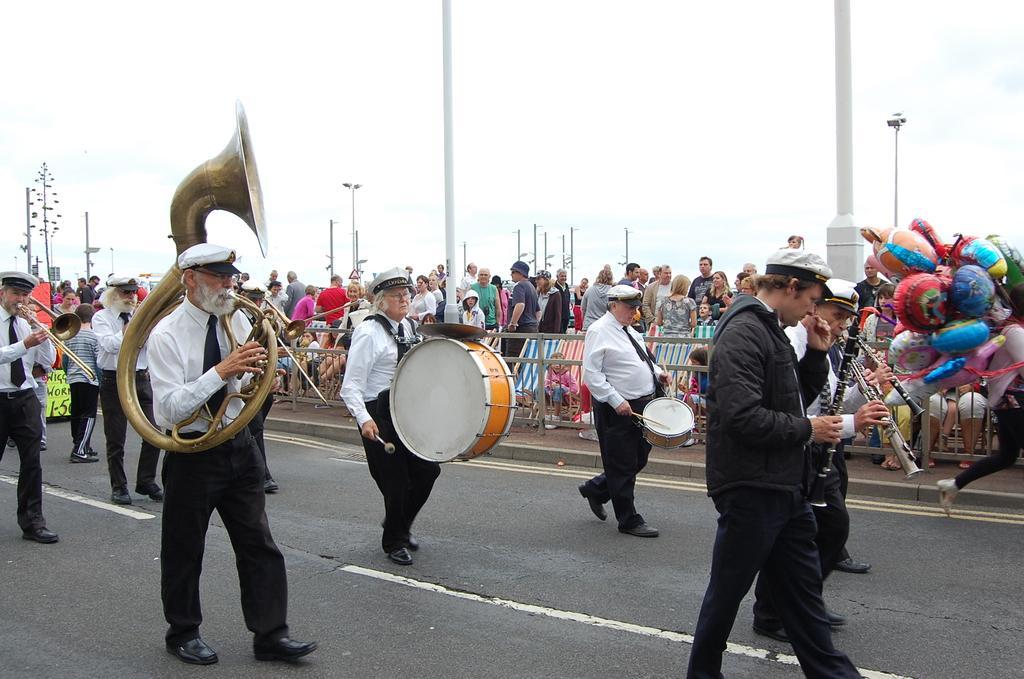Could you give a brief overview of what you see in this image? In the center of the image we can see people playing musical instruments on the road. On the right there is a person carrying balloons. In the background there are people, poles, lights and sky. There is a fence. 